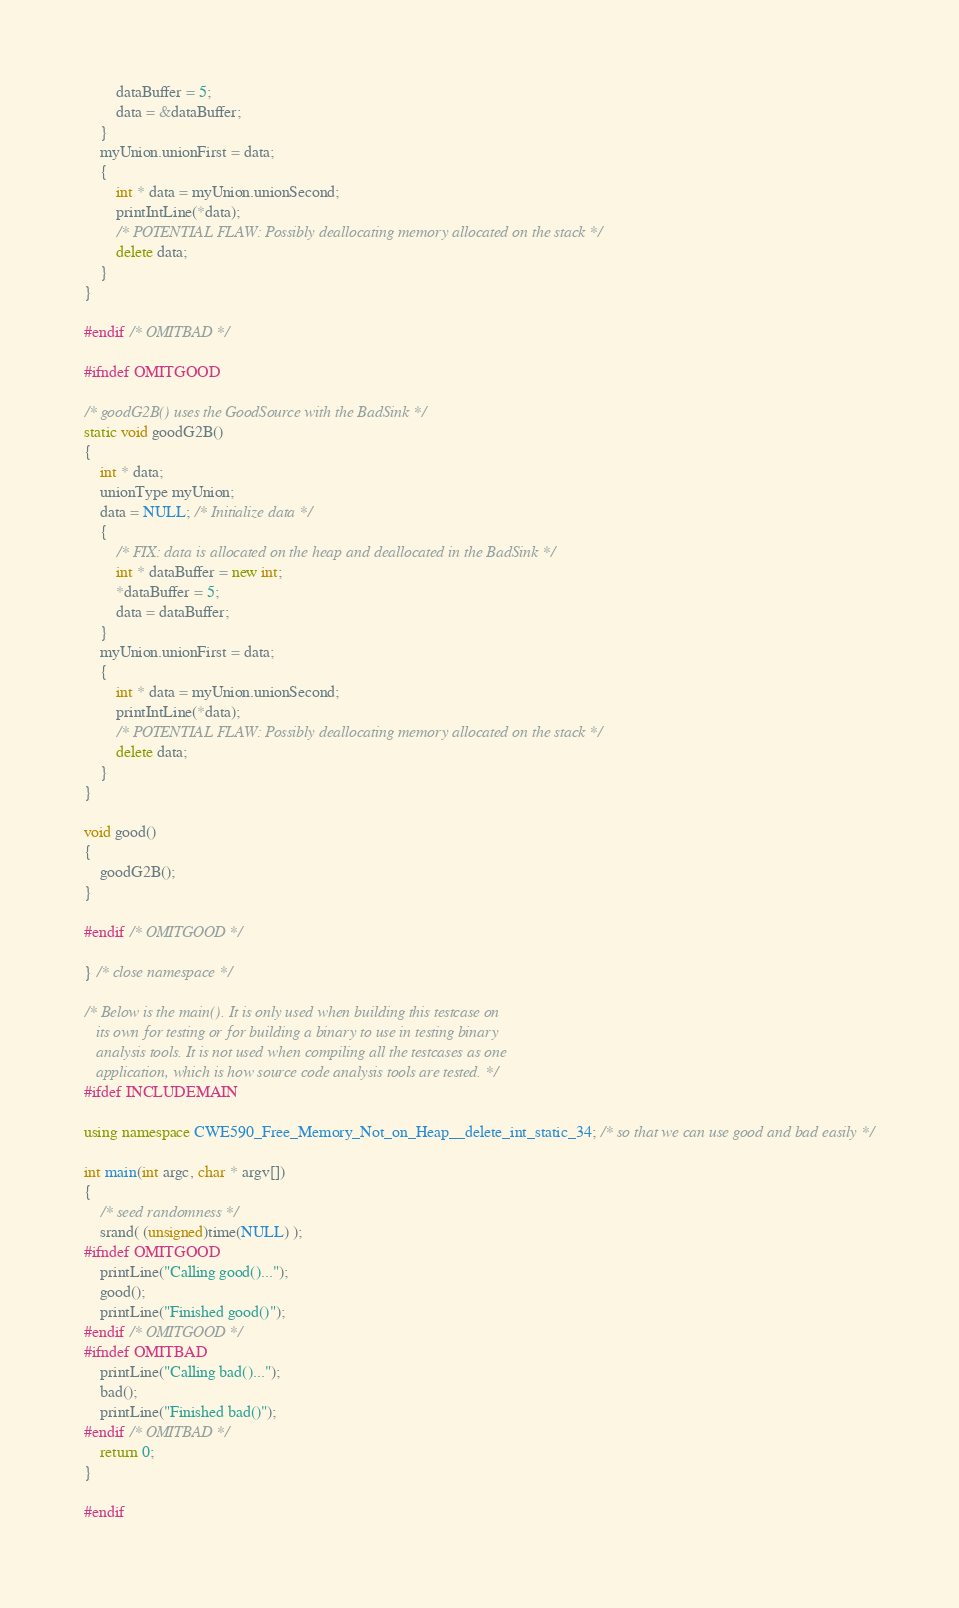Convert code to text. <code><loc_0><loc_0><loc_500><loc_500><_C++_>        dataBuffer = 5;
        data = &dataBuffer;
    }
    myUnion.unionFirst = data;
    {
        int * data = myUnion.unionSecond;
        printIntLine(*data);
        /* POTENTIAL FLAW: Possibly deallocating memory allocated on the stack */
        delete data;
    }
}

#endif /* OMITBAD */

#ifndef OMITGOOD

/* goodG2B() uses the GoodSource with the BadSink */
static void goodG2B()
{
    int * data;
    unionType myUnion;
    data = NULL; /* Initialize data */
    {
        /* FIX: data is allocated on the heap and deallocated in the BadSink */
        int * dataBuffer = new int;
        *dataBuffer = 5;
        data = dataBuffer;
    }
    myUnion.unionFirst = data;
    {
        int * data = myUnion.unionSecond;
        printIntLine(*data);
        /* POTENTIAL FLAW: Possibly deallocating memory allocated on the stack */
        delete data;
    }
}

void good()
{
    goodG2B();
}

#endif /* OMITGOOD */

} /* close namespace */

/* Below is the main(). It is only used when building this testcase on
   its own for testing or for building a binary to use in testing binary
   analysis tools. It is not used when compiling all the testcases as one
   application, which is how source code analysis tools are tested. */
#ifdef INCLUDEMAIN

using namespace CWE590_Free_Memory_Not_on_Heap__delete_int_static_34; /* so that we can use good and bad easily */

int main(int argc, char * argv[])
{
    /* seed randomness */
    srand( (unsigned)time(NULL) );
#ifndef OMITGOOD
    printLine("Calling good()...");
    good();
    printLine("Finished good()");
#endif /* OMITGOOD */
#ifndef OMITBAD
    printLine("Calling bad()...");
    bad();
    printLine("Finished bad()");
#endif /* OMITBAD */
    return 0;
}

#endif
</code> 